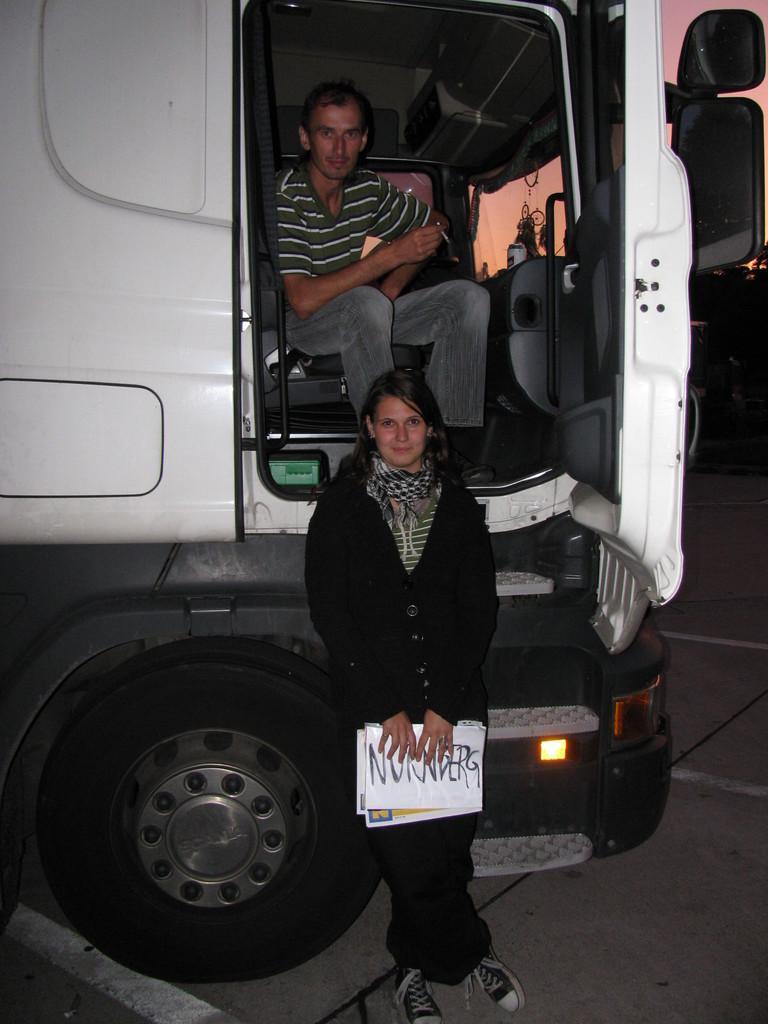Can you describe this image briefly? In this picture we can see a vehicle, man sitting on a chair and a woman holding papers with her hands and standing on the road and smiling and in the background we can see some objects. 